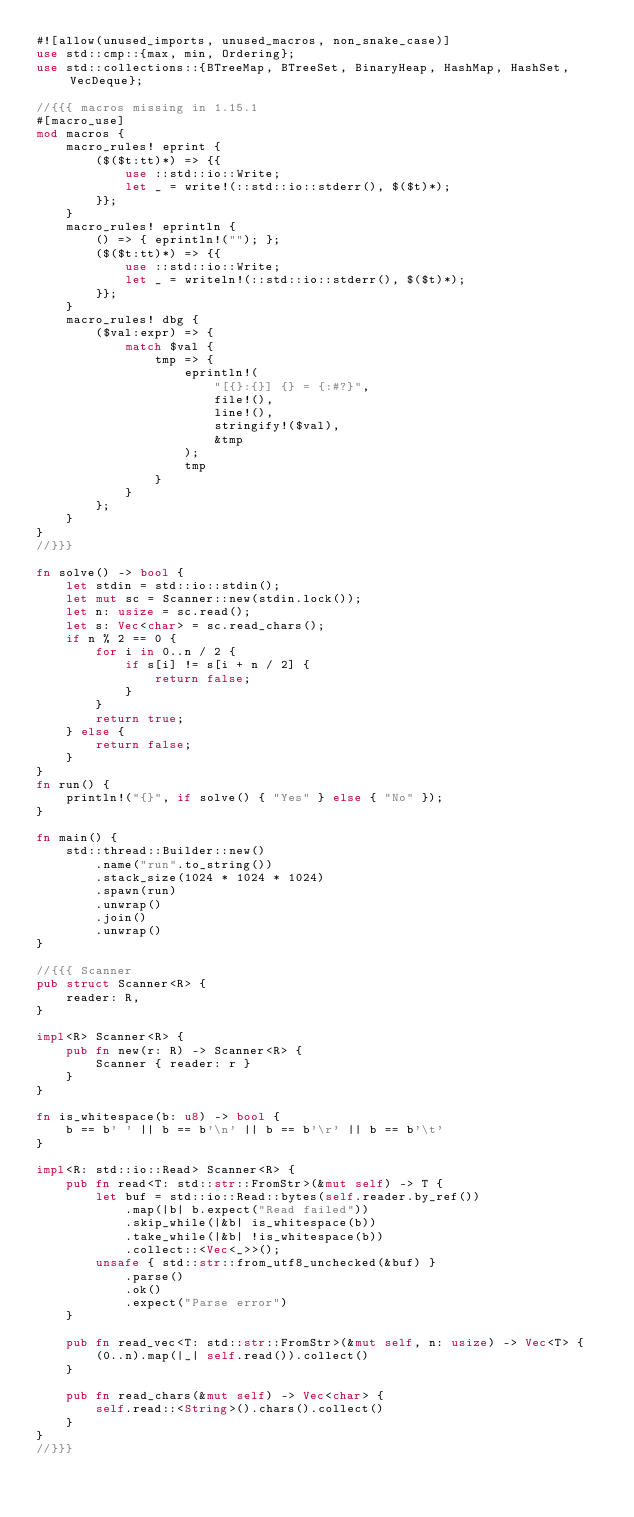Convert code to text. <code><loc_0><loc_0><loc_500><loc_500><_Rust_>#![allow(unused_imports, unused_macros, non_snake_case)]
use std::cmp::{max, min, Ordering};
use std::collections::{BTreeMap, BTreeSet, BinaryHeap, HashMap, HashSet, VecDeque};

//{{{ macros missing in 1.15.1
#[macro_use]
mod macros {
    macro_rules! eprint {
        ($($t:tt)*) => {{
            use ::std::io::Write;
            let _ = write!(::std::io::stderr(), $($t)*);
        }};
    }
    macro_rules! eprintln {
        () => { eprintln!(""); };
        ($($t:tt)*) => {{
            use ::std::io::Write;
            let _ = writeln!(::std::io::stderr(), $($t)*);
        }};
    }
    macro_rules! dbg {
        ($val:expr) => {
            match $val {
                tmp => {
                    eprintln!(
                        "[{}:{}] {} = {:#?}",
                        file!(),
                        line!(),
                        stringify!($val),
                        &tmp
                    );
                    tmp
                }
            }
        };
    }
}
//}}}

fn solve() -> bool {
    let stdin = std::io::stdin();
    let mut sc = Scanner::new(stdin.lock());
    let n: usize = sc.read();
    let s: Vec<char> = sc.read_chars();
    if n % 2 == 0 {
        for i in 0..n / 2 {
            if s[i] != s[i + n / 2] {
                return false;
            }
        }
        return true;
    } else {
        return false;
    }
}
fn run() {
    println!("{}", if solve() { "Yes" } else { "No" });
}

fn main() {
    std::thread::Builder::new()
        .name("run".to_string())
        .stack_size(1024 * 1024 * 1024)
        .spawn(run)
        .unwrap()
        .join()
        .unwrap()
}

//{{{ Scanner
pub struct Scanner<R> {
    reader: R,
}

impl<R> Scanner<R> {
    pub fn new(r: R) -> Scanner<R> {
        Scanner { reader: r }
    }
}

fn is_whitespace(b: u8) -> bool {
    b == b' ' || b == b'\n' || b == b'\r' || b == b'\t'
}

impl<R: std::io::Read> Scanner<R> {
    pub fn read<T: std::str::FromStr>(&mut self) -> T {
        let buf = std::io::Read::bytes(self.reader.by_ref())
            .map(|b| b.expect("Read failed"))
            .skip_while(|&b| is_whitespace(b))
            .take_while(|&b| !is_whitespace(b))
            .collect::<Vec<_>>();
        unsafe { std::str::from_utf8_unchecked(&buf) }
            .parse()
            .ok()
            .expect("Parse error")
    }

    pub fn read_vec<T: std::str::FromStr>(&mut self, n: usize) -> Vec<T> {
        (0..n).map(|_| self.read()).collect()
    }

    pub fn read_chars(&mut self) -> Vec<char> {
        self.read::<String>().chars().collect()
    }
}
//}}}
</code> 